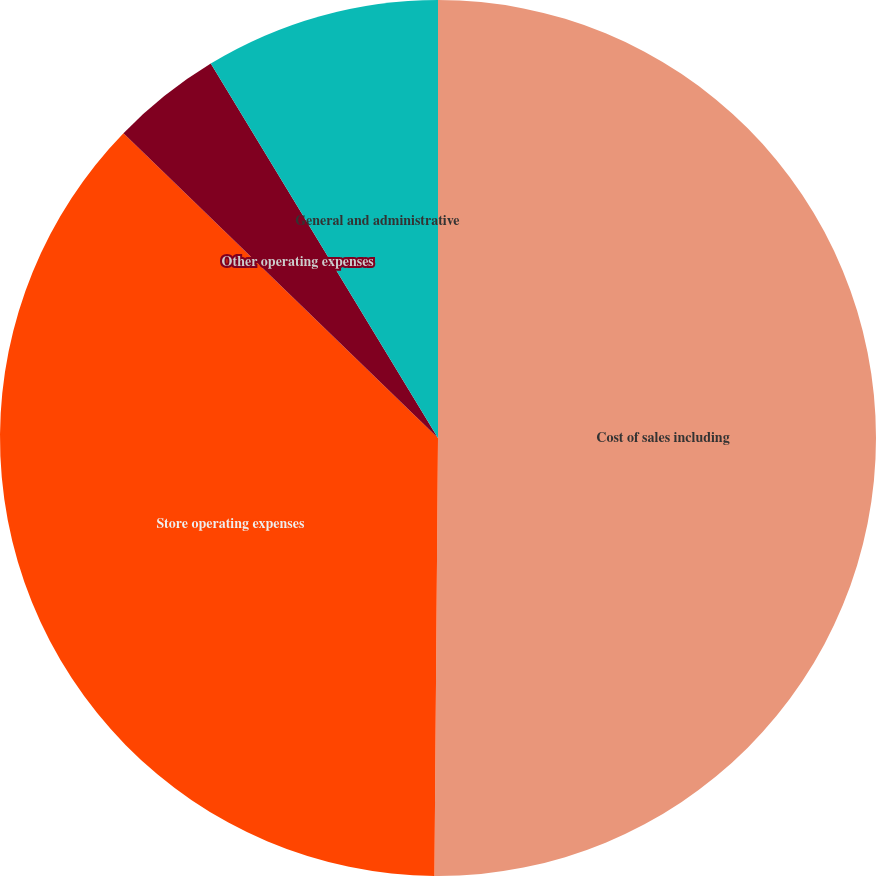<chart> <loc_0><loc_0><loc_500><loc_500><pie_chart><fcel>Cost of sales including<fcel>Store operating expenses<fcel>Other operating expenses<fcel>General and administrative<nl><fcel>50.13%<fcel>37.12%<fcel>4.07%<fcel>8.68%<nl></chart> 